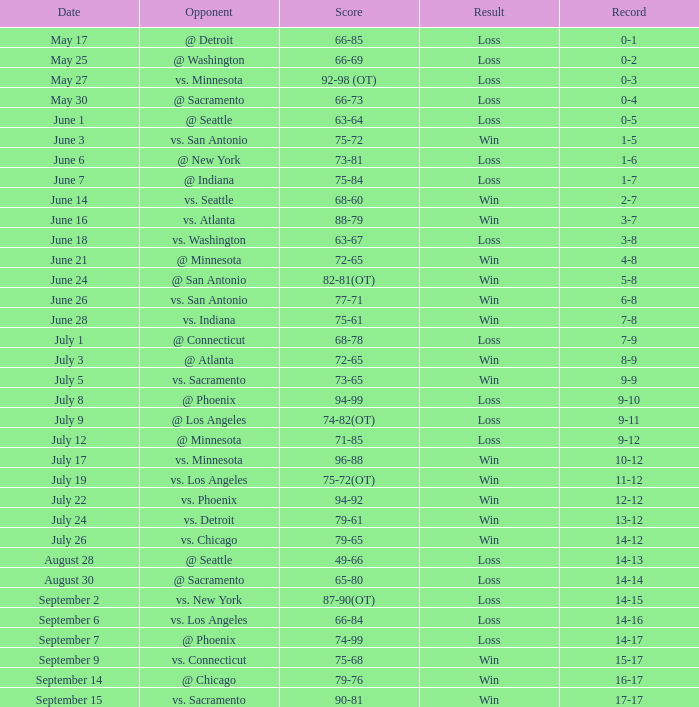What was the Score of the game with a Record of 0-1? 66-85. Parse the full table. {'header': ['Date', 'Opponent', 'Score', 'Result', 'Record'], 'rows': [['May 17', '@ Detroit', '66-85', 'Loss', '0-1'], ['May 25', '@ Washington', '66-69', 'Loss', '0-2'], ['May 27', 'vs. Minnesota', '92-98 (OT)', 'Loss', '0-3'], ['May 30', '@ Sacramento', '66-73', 'Loss', '0-4'], ['June 1', '@ Seattle', '63-64', 'Loss', '0-5'], ['June 3', 'vs. San Antonio', '75-72', 'Win', '1-5'], ['June 6', '@ New York', '73-81', 'Loss', '1-6'], ['June 7', '@ Indiana', '75-84', 'Loss', '1-7'], ['June 14', 'vs. Seattle', '68-60', 'Win', '2-7'], ['June 16', 'vs. Atlanta', '88-79', 'Win', '3-7'], ['June 18', 'vs. Washington', '63-67', 'Loss', '3-8'], ['June 21', '@ Minnesota', '72-65', 'Win', '4-8'], ['June 24', '@ San Antonio', '82-81(OT)', 'Win', '5-8'], ['June 26', 'vs. San Antonio', '77-71', 'Win', '6-8'], ['June 28', 'vs. Indiana', '75-61', 'Win', '7-8'], ['July 1', '@ Connecticut', '68-78', 'Loss', '7-9'], ['July 3', '@ Atlanta', '72-65', 'Win', '8-9'], ['July 5', 'vs. Sacramento', '73-65', 'Win', '9-9'], ['July 8', '@ Phoenix', '94-99', 'Loss', '9-10'], ['July 9', '@ Los Angeles', '74-82(OT)', 'Loss', '9-11'], ['July 12', '@ Minnesota', '71-85', 'Loss', '9-12'], ['July 17', 'vs. Minnesota', '96-88', 'Win', '10-12'], ['July 19', 'vs. Los Angeles', '75-72(OT)', 'Win', '11-12'], ['July 22', 'vs. Phoenix', '94-92', 'Win', '12-12'], ['July 24', 'vs. Detroit', '79-61', 'Win', '13-12'], ['July 26', 'vs. Chicago', '79-65', 'Win', '14-12'], ['August 28', '@ Seattle', '49-66', 'Loss', '14-13'], ['August 30', '@ Sacramento', '65-80', 'Loss', '14-14'], ['September 2', 'vs. New York', '87-90(OT)', 'Loss', '14-15'], ['September 6', 'vs. Los Angeles', '66-84', 'Loss', '14-16'], ['September 7', '@ Phoenix', '74-99', 'Loss', '14-17'], ['September 9', 'vs. Connecticut', '75-68', 'Win', '15-17'], ['September 14', '@ Chicago', '79-76', 'Win', '16-17'], ['September 15', 'vs. Sacramento', '90-81', 'Win', '17-17']]} 